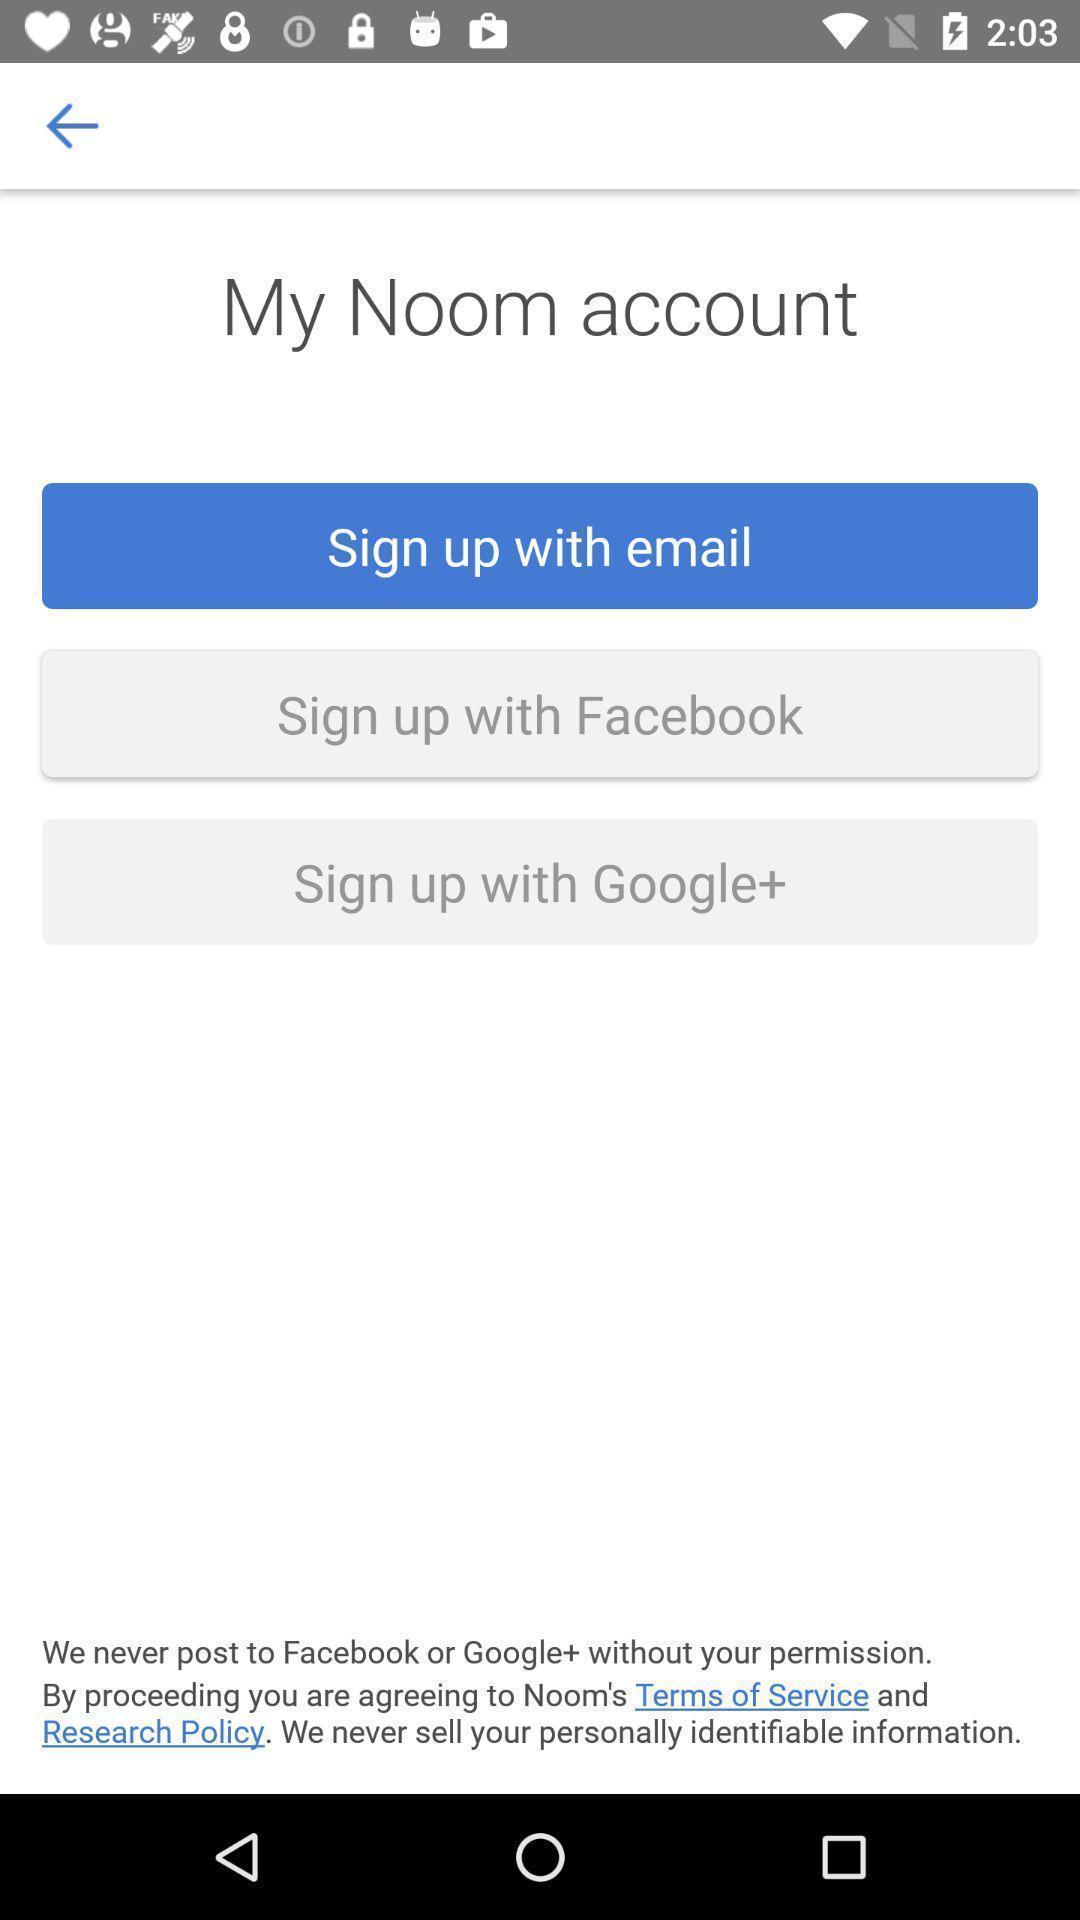Give me a narrative description of this picture. Start page displaying various sign up options in fitness app. 